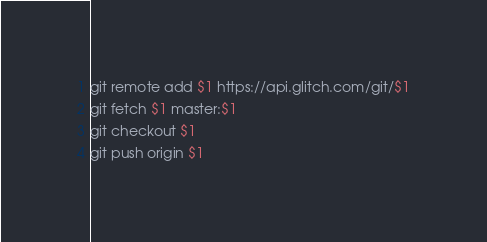<code> <loc_0><loc_0><loc_500><loc_500><_Bash_>git remote add $1 https://api.glitch.com/git/$1
git fetch $1 master:$1
git checkout $1
git push origin $1

</code> 